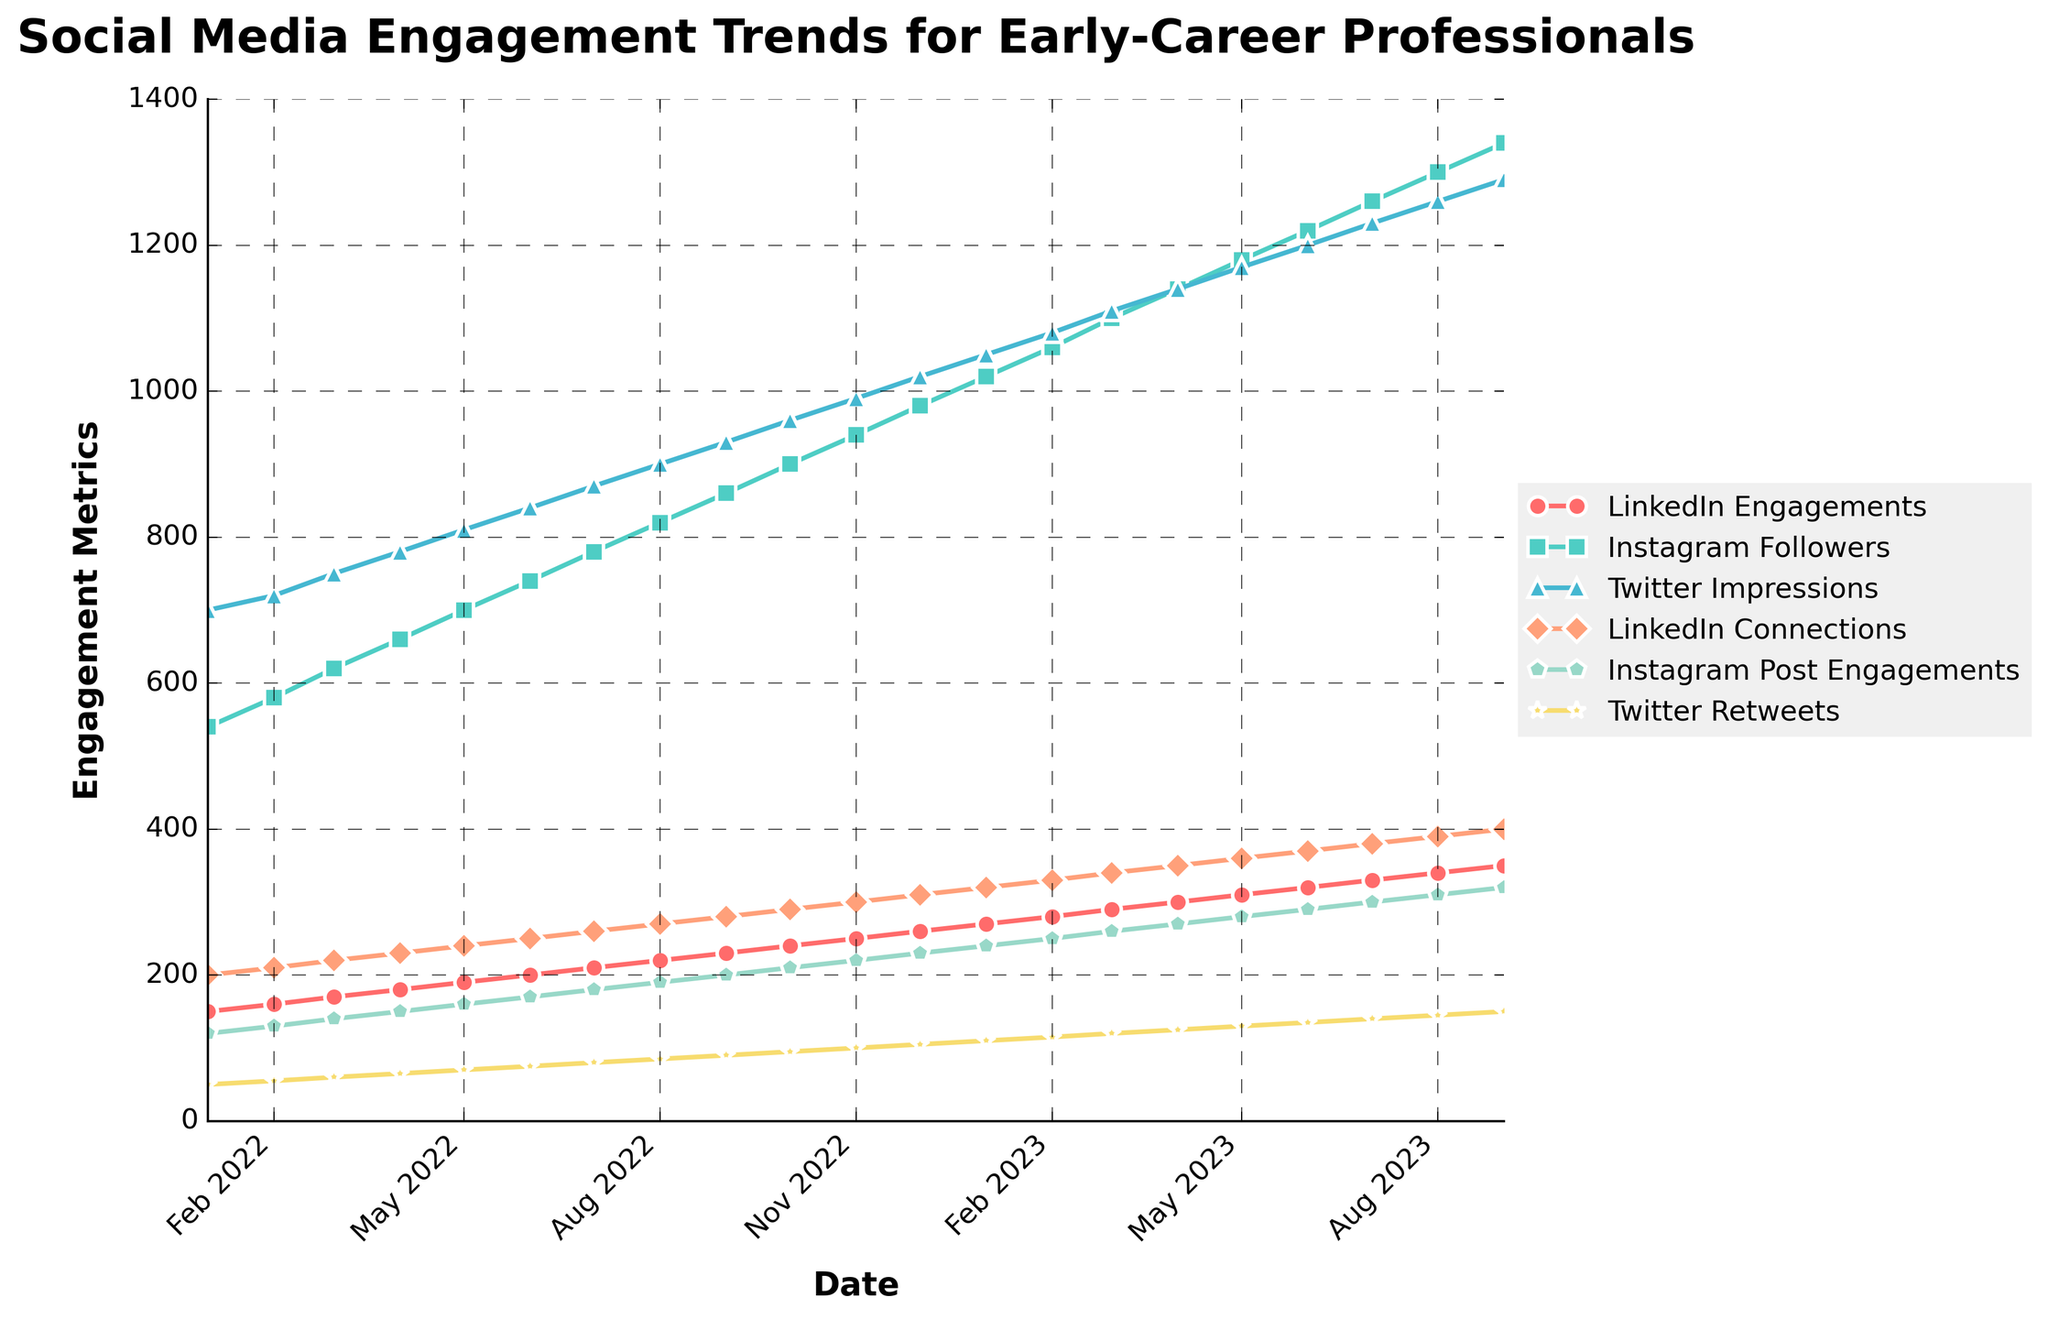What's the title of the figure? Looking at the top of the figure, we can clearly see the title prominently displayed.
Answer: Social Media Engagement Trends for Early-Career Professionals How many data points are there for each metric? The x-axis covers dates from January 2022 to September 2023. Counting each monthly data point, we see there are 21 data points.
Answer: 21 What color represents LinkedIn Engagements? The figure uses different colors for each metric. The color red identifies LinkedIn Engagements.
Answer: Red Which metric shows the highest value in August 2023? In August 2023, the highest y-axis value across all plots can be identified. Instagram Followers peak at 1300.
Answer: Instagram Followers How does the number of Instagram Followers change from July 2022 to July 2023? Check the data points for Instagram Followers in July 2022 and July 2023. The values are 780 and 1260 respectively. Subtract 780 from 1260 to find the increase.
Answer: 480 On which month do Twitter Impressions first surpass 1000? Look at Twitter Impressions data and find the point where it first exceeds 1000. This happens in December 2022.
Answer: December 2022 What’s the average number of LinkedIn Connections in the first quarter of 2023? January, February, and March 2023 data for LinkedIn Connections are 320, 330, and 340. Sum these values and divide by 3 (320 + 330 + 340) / 3 = 330.
Answer: 330 Did Twitter Retweets ever surpass Instagram Post Engagements? Compare the Twitter Retweets and Instagram Post Engagements curves. Twitter Retweets are persistently lower than Instagram Post Engagements.
Answer: No What trend is observed in Instagram Followers from the start to end of the period? The line for Instagram Followers steadily rises from January 2022, starting at 540 and climbing to 1340 in September 2023.
Answer: Increasing In which month did all metrics show upward movement compared to the previous month? Inspect the lines to find a month where each metric rose from the previous month. April 2023, all metrics increased: LinkedIn Engagements (300), Instagram Followers (1140), Twitter Impressions (1140), LinkedIn Connections (350), Instagram Post Engagements (270), and Twitter Retweets (125).
Answer: April 2023 